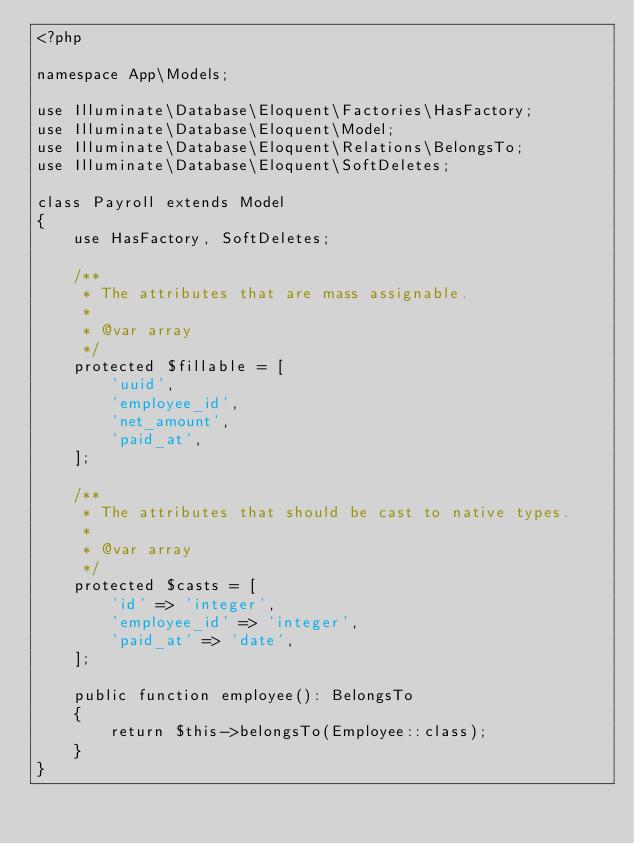<code> <loc_0><loc_0><loc_500><loc_500><_PHP_><?php

namespace App\Models;

use Illuminate\Database\Eloquent\Factories\HasFactory;
use Illuminate\Database\Eloquent\Model;
use Illuminate\Database\Eloquent\Relations\BelongsTo;
use Illuminate\Database\Eloquent\SoftDeletes;

class Payroll extends Model
{
    use HasFactory, SoftDeletes;

    /**
     * The attributes that are mass assignable.
     *
     * @var array
     */
    protected $fillable = [
        'uuid',
        'employee_id',
        'net_amount',
        'paid_at',
    ];

    /**
     * The attributes that should be cast to native types.
     *
     * @var array
     */
    protected $casts = [
        'id' => 'integer',
        'employee_id' => 'integer',
        'paid_at' => 'date',
    ];

    public function employee(): BelongsTo
    {
        return $this->belongsTo(Employee::class);
    }
}
</code> 